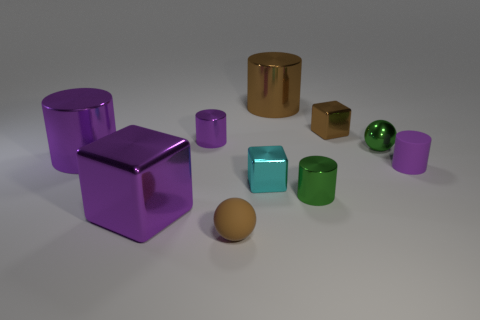Subtract all tiny metallic cylinders. How many cylinders are left? 3 Subtract all brown blocks. How many blocks are left? 2 Subtract all red spheres. How many green cylinders are left? 1 Subtract 2 cylinders. How many cylinders are left? 3 Subtract all blue balls. Subtract all brown cubes. How many balls are left? 2 Subtract all big brown metal cylinders. Subtract all small cylinders. How many objects are left? 6 Add 1 tiny cyan metallic things. How many tiny cyan metallic things are left? 2 Add 5 brown cylinders. How many brown cylinders exist? 6 Subtract 0 purple balls. How many objects are left? 10 Subtract all spheres. How many objects are left? 8 